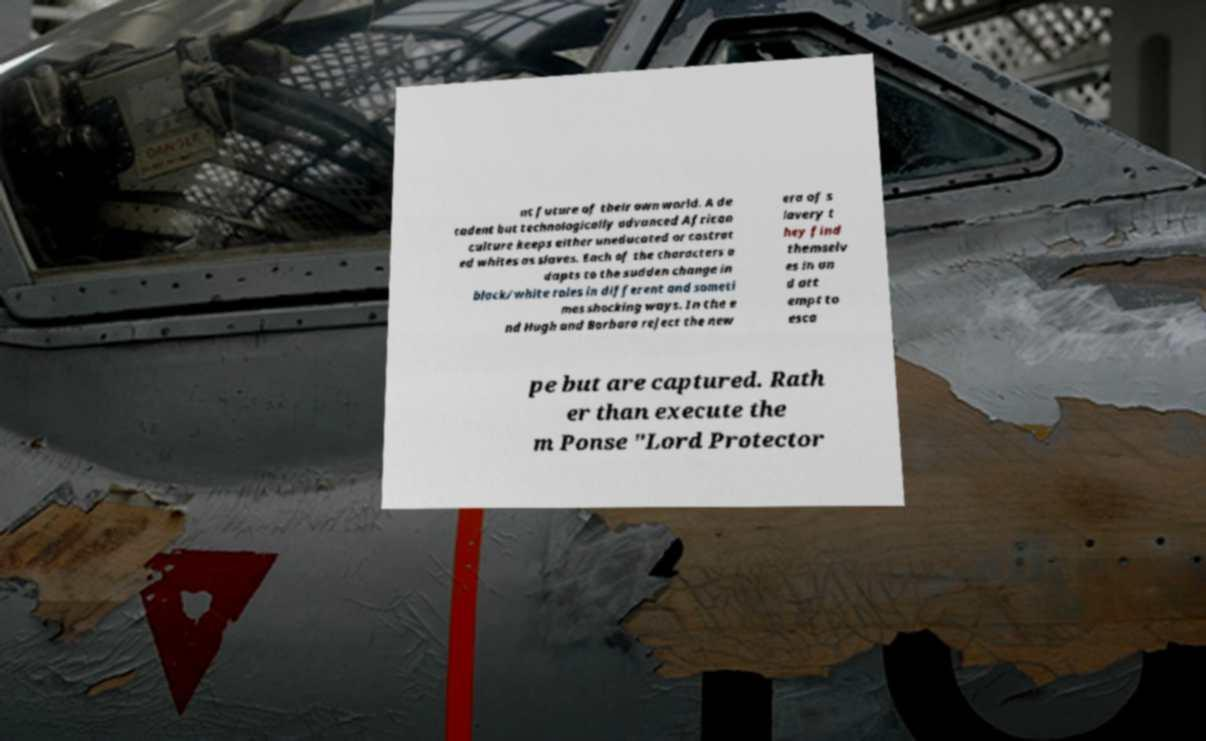I need the written content from this picture converted into text. Can you do that? nt future of their own world. A de cadent but technologically advanced African culture keeps either uneducated or castrat ed whites as slaves. Each of the characters a dapts to the sudden change in black/white roles in different and someti mes shocking ways. In the e nd Hugh and Barbara reject the new era of s lavery t hey find themselv es in an d att empt to esca pe but are captured. Rath er than execute the m Ponse "Lord Protector 